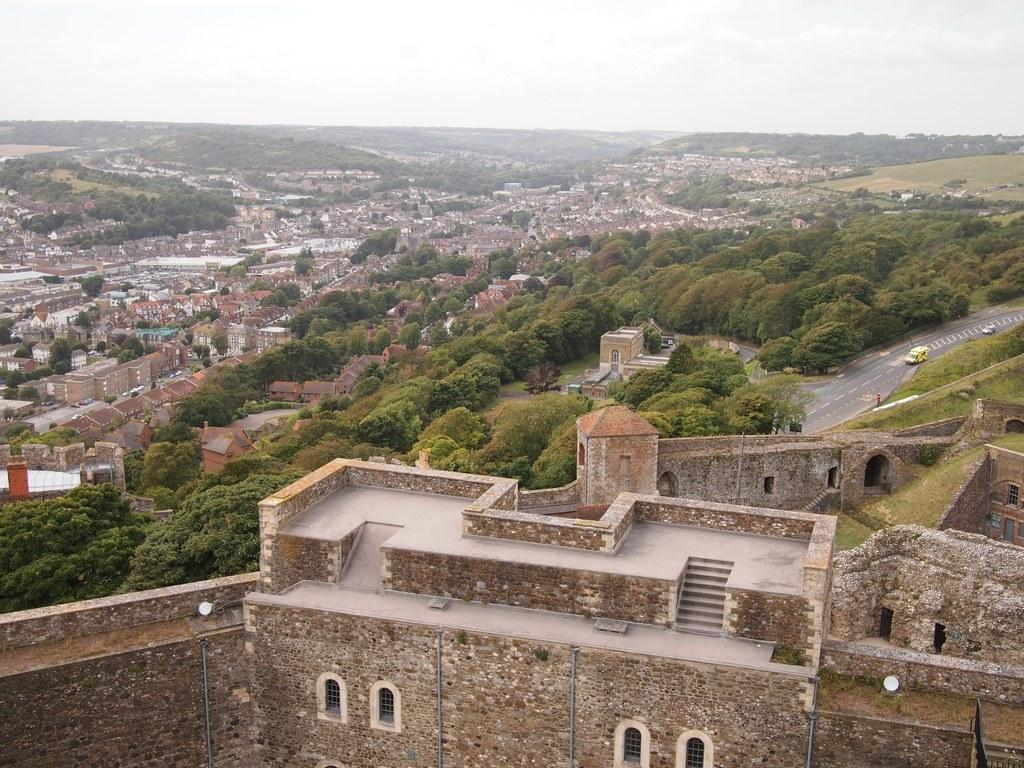What types of structures are present in the image? There are buildings and houses in the image. What can be seen in the image besides structures? There is a group of trees, vehicles on the ground, grass, and the sky visible in the image. How would you describe the sky in the image? The sky appears cloudy in the image. Where is the table located in the image? There is no table present in the image. What trick is being performed with the throat in the image? There is no trick or throat-related activity depicted in the image. 